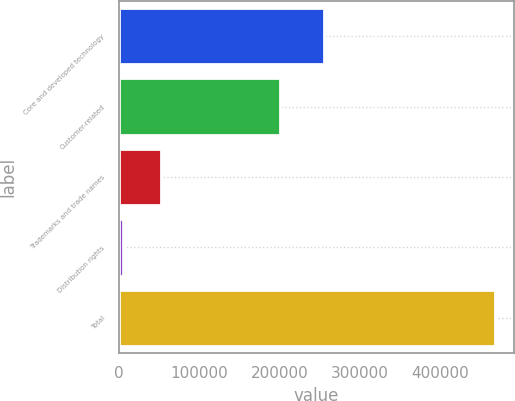Convert chart to OTSL. <chart><loc_0><loc_0><loc_500><loc_500><bar_chart><fcel>Core and developed technology<fcel>Customer-related<fcel>Trademarks and trade names<fcel>Distribution rights<fcel>Total<nl><fcel>255460<fcel>200331<fcel>51638.2<fcel>5302<fcel>468664<nl></chart> 